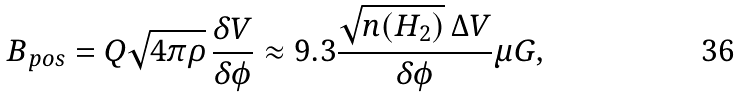Convert formula to latex. <formula><loc_0><loc_0><loc_500><loc_500>B _ { p o s } = Q \sqrt { 4 \pi \rho } \, \frac { \delta V } { \delta \phi } \approx 9 . 3 \frac { \sqrt { n ( H _ { 2 } ) } \, \Delta V } { \delta \phi } \mu G ,</formula> 